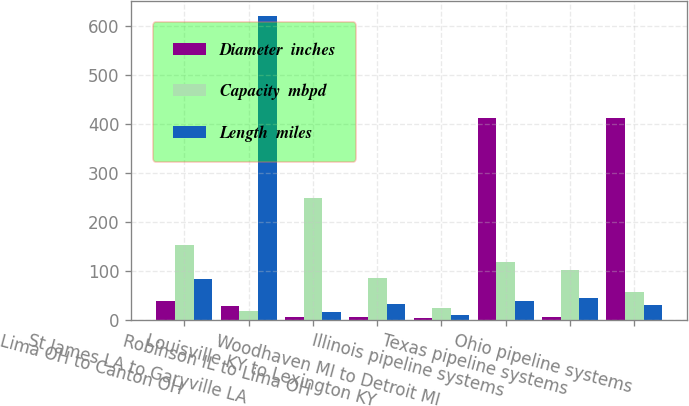Convert chart. <chart><loc_0><loc_0><loc_500><loc_500><stacked_bar_chart><ecel><fcel>Lima OH to Canton OH<fcel>St James LA to Garyville LA<fcel>Robinson IL to Lima OH<fcel>Louisville KY to Lexington KY<fcel>Woodhaven MI to Detroit MI<fcel>Illinois pipeline systems<fcel>Texas pipeline systems<fcel>Ohio pipeline systems<nl><fcel>Diameter  inches<fcel>39<fcel>30<fcel>8<fcel>8<fcel>4<fcel>412<fcel>8<fcel>412<nl><fcel>Capacity  mbpd<fcel>153<fcel>20<fcel>250<fcel>87<fcel>26<fcel>118<fcel>103<fcel>57<nl><fcel>Length  miles<fcel>84<fcel>620<fcel>18<fcel>34<fcel>11<fcel>39<fcel>45<fcel>32<nl></chart> 